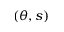Convert formula to latex. <formula><loc_0><loc_0><loc_500><loc_500>( \theta , s )</formula> 